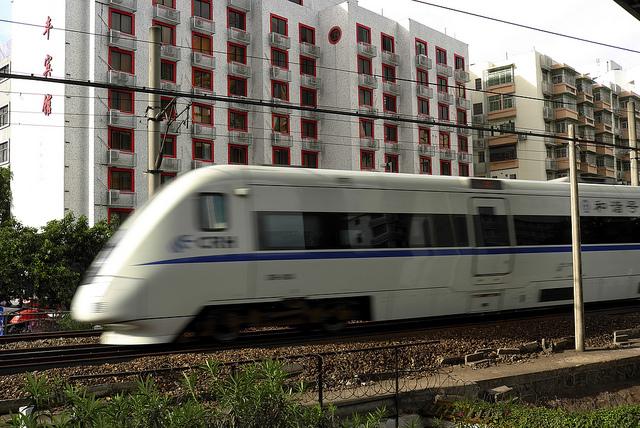Is the train speeding?
Keep it brief. Yes. Is the a train in the US?
Short answer required. No. What color is the train?
Be succinct. White. Are those English characters on the left side of the left building?
Write a very short answer. No. 